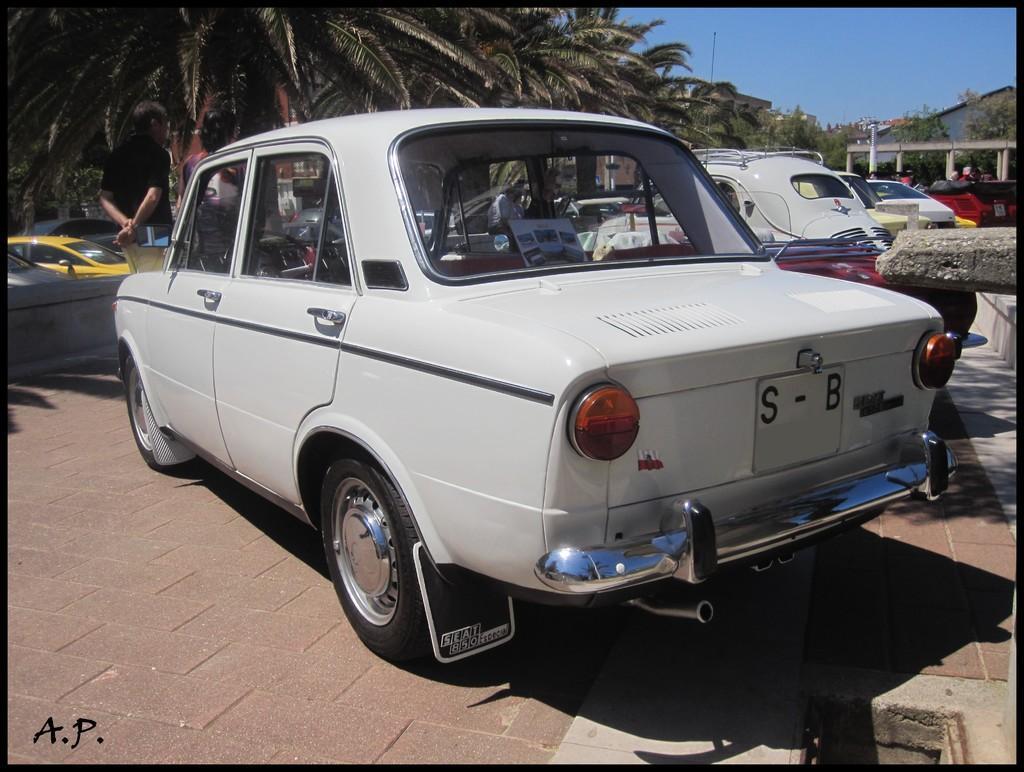Please provide a concise description of this image. In this picture I can see few vehicles in the middle, on the left side I can see a person. In the background there are trees, on the right side I can see few buildings, at the top there is the sky, in the bottom right hand side I can see the text. 